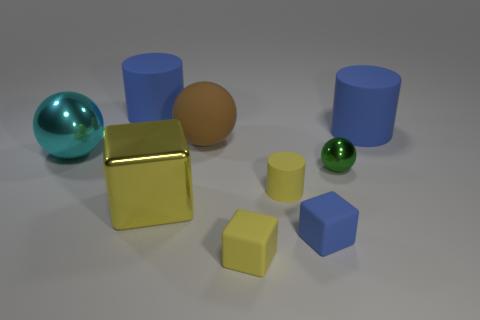Is there a blue cube in front of the rubber cylinder that is to the left of the big yellow shiny cube?
Offer a terse response. Yes. Does the brown rubber ball have the same size as the yellow rubber cylinder?
Provide a succinct answer. No. What material is the large blue object in front of the large blue rubber object that is on the left side of the metallic object that is in front of the small green shiny object?
Your response must be concise. Rubber. Are there an equal number of yellow cylinders that are on the right side of the green metallic ball and large red metal cylinders?
Make the answer very short. Yes. What number of objects are small blue blocks or large things?
Provide a short and direct response. 6. There is a small blue thing that is the same material as the large brown ball; what shape is it?
Make the answer very short. Cube. There is a yellow object that is on the left side of the sphere that is behind the large metallic sphere; what is its size?
Provide a succinct answer. Large. How many tiny objects are either metal things or green shiny spheres?
Ensure brevity in your answer.  1. What number of other things are there of the same color as the small cylinder?
Provide a short and direct response. 2. There is a metallic ball on the left side of the yellow cylinder; is it the same size as the metal sphere right of the large shiny ball?
Provide a short and direct response. No. 